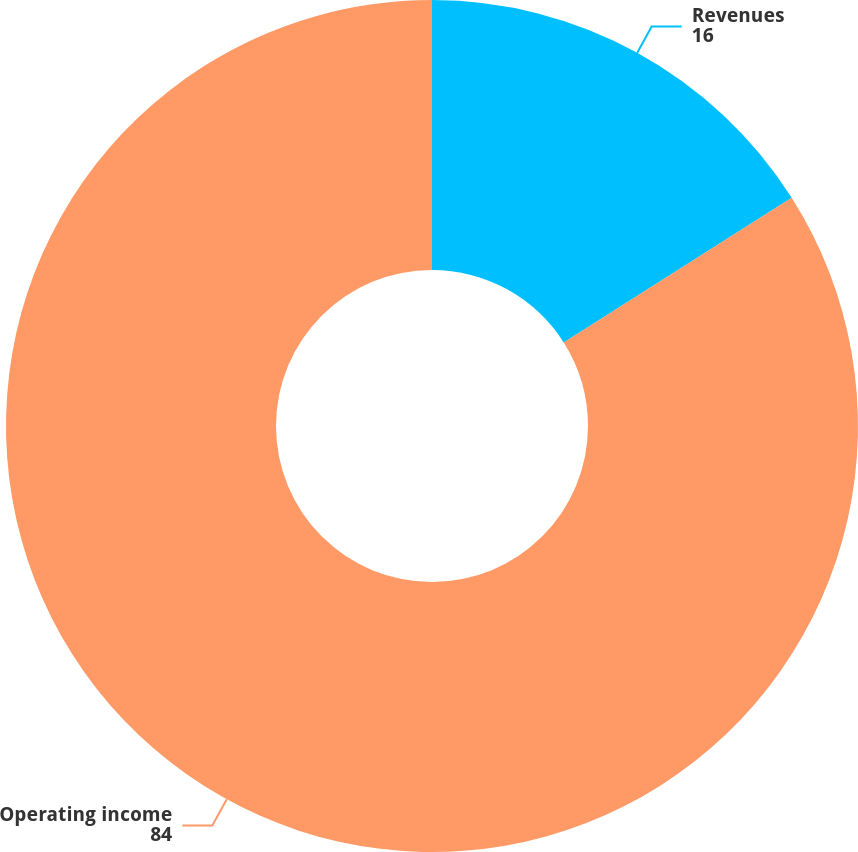<chart> <loc_0><loc_0><loc_500><loc_500><pie_chart><fcel>Revenues<fcel>Operating income<nl><fcel>16.0%<fcel>84.0%<nl></chart> 